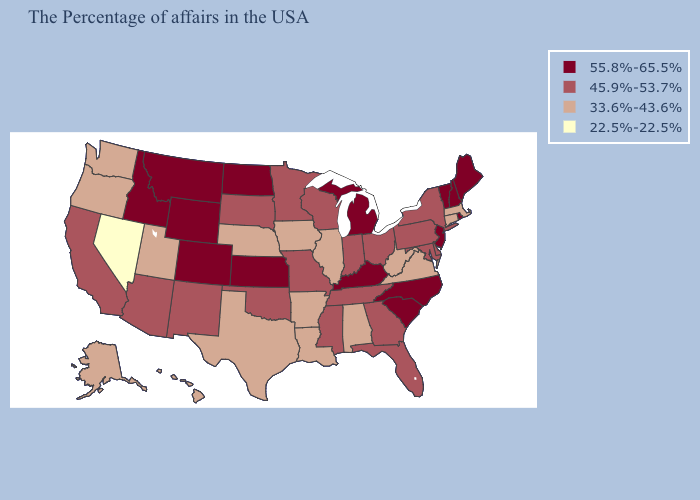Name the states that have a value in the range 55.8%-65.5%?
Give a very brief answer. Maine, Rhode Island, New Hampshire, Vermont, New Jersey, North Carolina, South Carolina, Michigan, Kentucky, Kansas, North Dakota, Wyoming, Colorado, Montana, Idaho. What is the lowest value in the Northeast?
Give a very brief answer. 33.6%-43.6%. What is the value of Alaska?
Give a very brief answer. 33.6%-43.6%. Does Delaware have a lower value than Kansas?
Be succinct. Yes. How many symbols are there in the legend?
Concise answer only. 4. How many symbols are there in the legend?
Quick response, please. 4. Name the states that have a value in the range 45.9%-53.7%?
Concise answer only. New York, Delaware, Maryland, Pennsylvania, Ohio, Florida, Georgia, Indiana, Tennessee, Wisconsin, Mississippi, Missouri, Minnesota, Oklahoma, South Dakota, New Mexico, Arizona, California. Which states hav the highest value in the West?
Give a very brief answer. Wyoming, Colorado, Montana, Idaho. Does New Hampshire have the same value as South Carolina?
Give a very brief answer. Yes. Does Rhode Island have the same value as Pennsylvania?
Quick response, please. No. What is the lowest value in states that border Florida?
Be succinct. 33.6%-43.6%. Does New Jersey have a higher value than Illinois?
Answer briefly. Yes. Does the first symbol in the legend represent the smallest category?
Answer briefly. No. What is the highest value in the USA?
Keep it brief. 55.8%-65.5%. What is the lowest value in the USA?
Give a very brief answer. 22.5%-22.5%. 